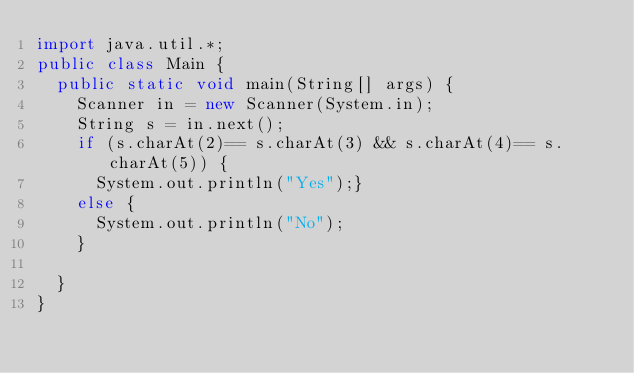<code> <loc_0><loc_0><loc_500><loc_500><_Java_>import java.util.*;
public class Main {
	public static void main(String[] args) {
		Scanner in = new Scanner(System.in);
		String s = in.next();
		if (s.charAt(2)== s.charAt(3) && s.charAt(4)== s.charAt(5)) {
			System.out.println("Yes");}
		else {
			System.out.println("No");
		}

	}
}</code> 